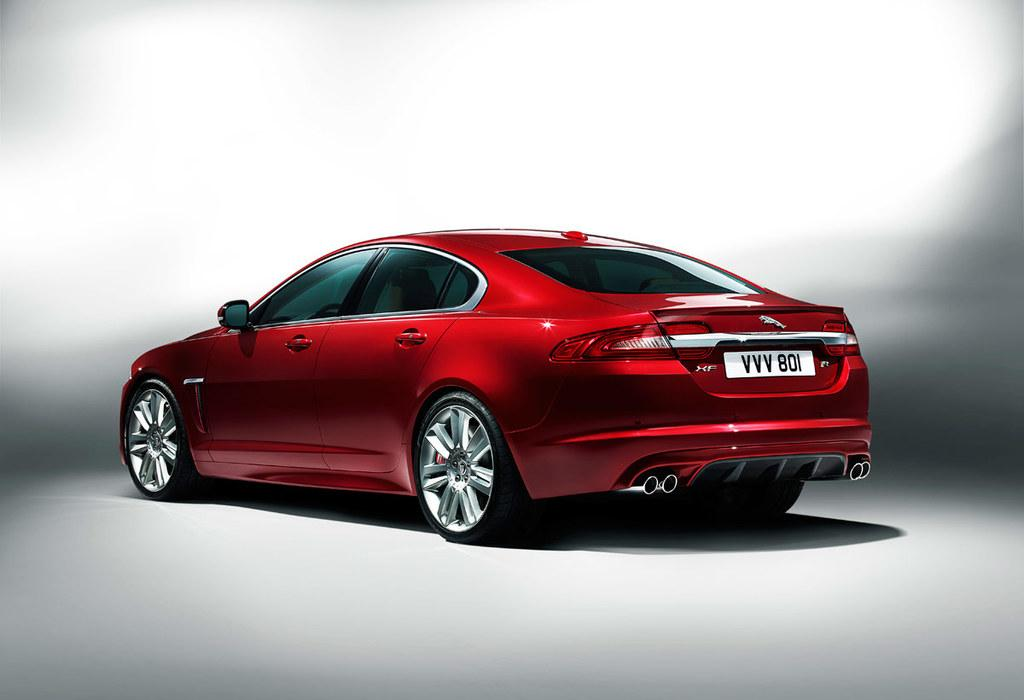What is the main subject of the image? There is a car in the image. Can you see any ants carrying the vessel across the ocean in the image? There is no vessel, ocean, or ants present in the image; it features a car. 